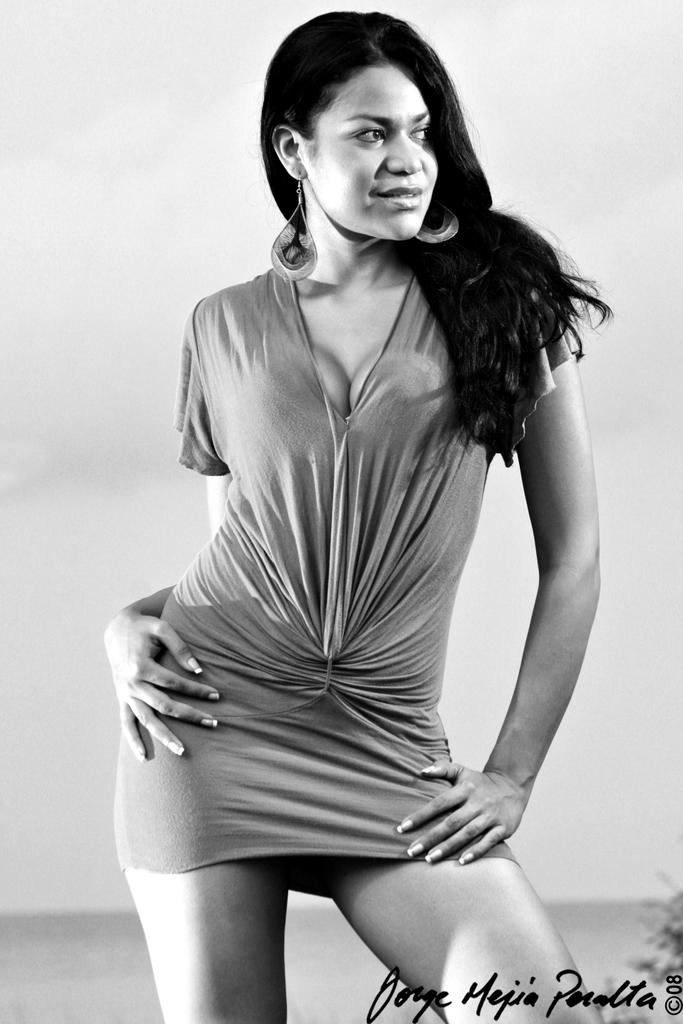What is the color scheme of the image? The image is black and white. Who is present in the image? There is a lady in the image. What is the lady wearing in the image? The lady is wearing a dress and earrings in the image. Is there any additional information about the image? Yes, there is a watermark in the right corner of the image. What type of toothbrush is the lady using in the image? There is no toothbrush present in the image. Is the lady getting a haircut in the image? There is no indication of a haircut in the image; the lady is simply standing there. 